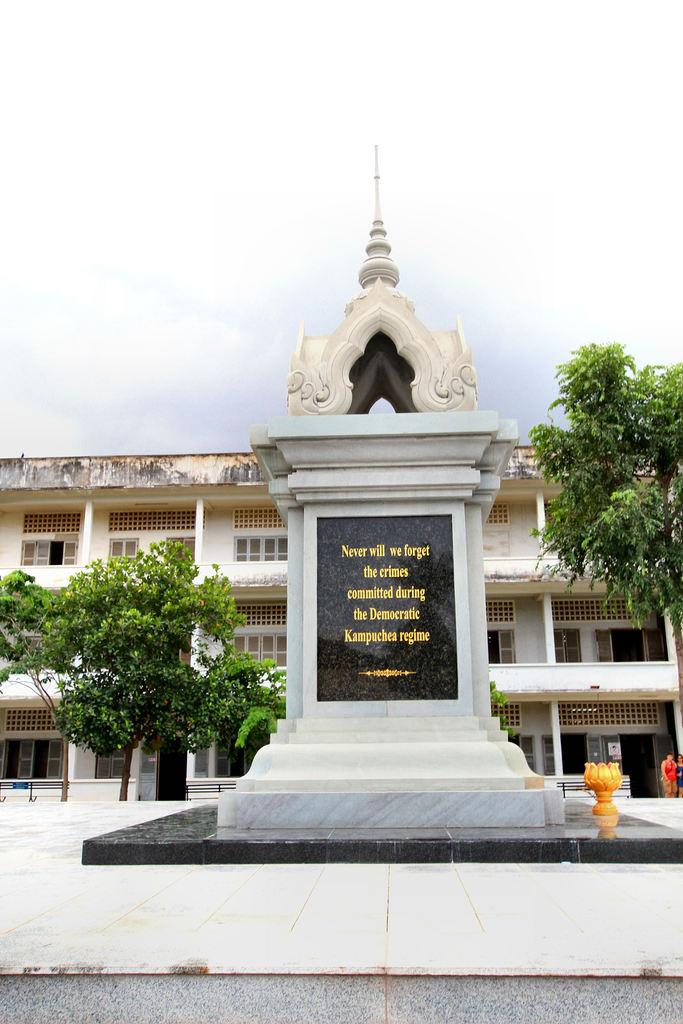<image>
Render a clear and concise summary of the photo. The plaque ensures that no one will ever forget the crimes committed during this particular regime. 